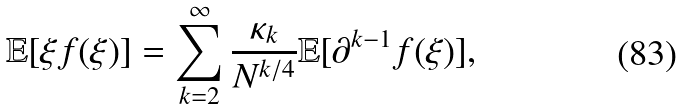<formula> <loc_0><loc_0><loc_500><loc_500>\mathbb { E } [ \xi f ( \xi ) ] = \sum _ { k = 2 } ^ { \infty } \frac { \kappa _ { k } } { N ^ { k / 4 } } \mathbb { E } [ \partial ^ { k - 1 } f ( \xi ) ] ,</formula> 